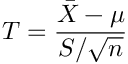Convert formula to latex. <formula><loc_0><loc_0><loc_500><loc_500>T = { \frac { { \bar { X } } - \mu } { S / { \sqrt { n } } } }</formula> 